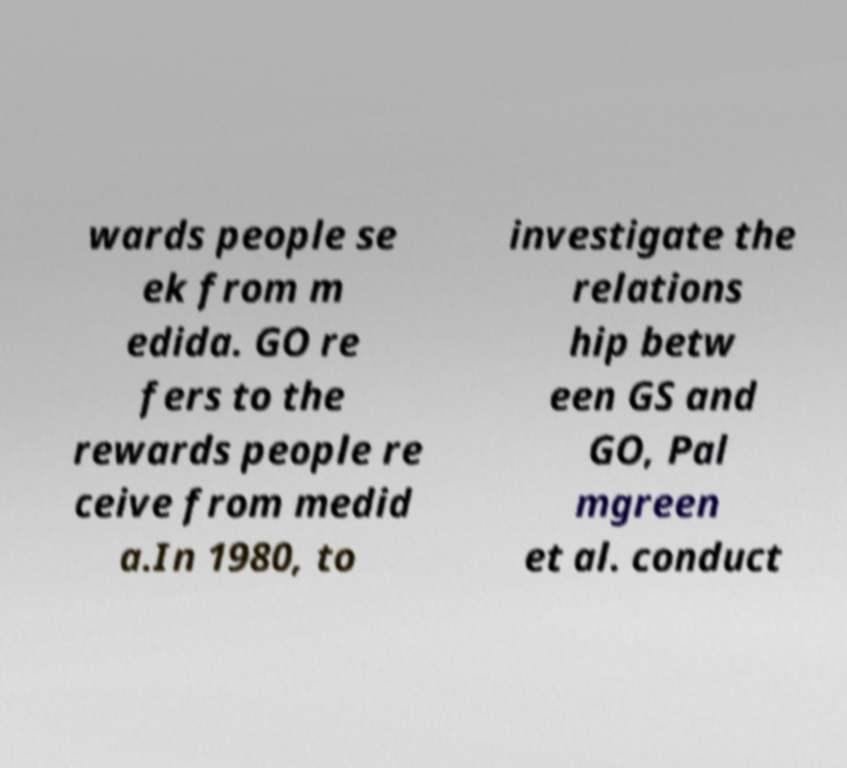Please read and relay the text visible in this image. What does it say? wards people se ek from m edida. GO re fers to the rewards people re ceive from medid a.In 1980, to investigate the relations hip betw een GS and GO, Pal mgreen et al. conduct 